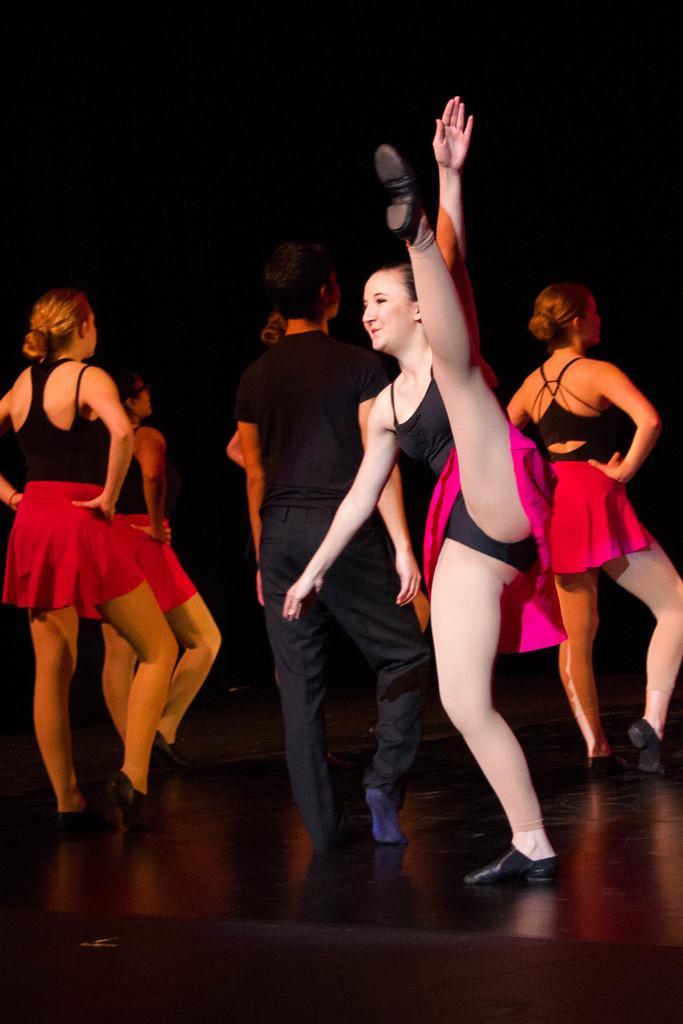Please provide a concise description of this image. There are some people dancing on the stage. In the background it is black. 